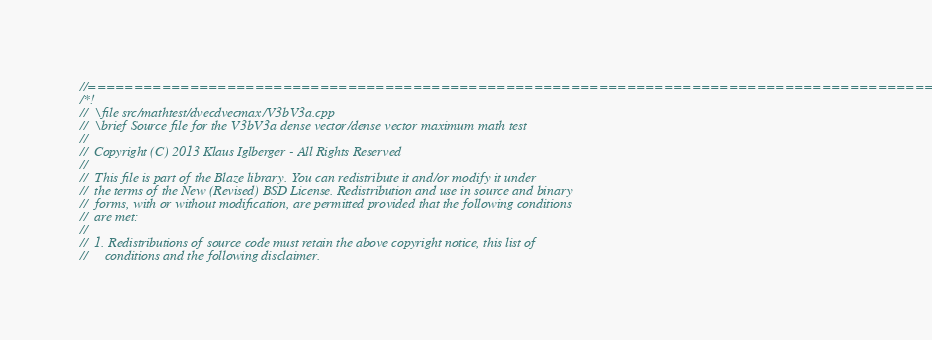Convert code to text. <code><loc_0><loc_0><loc_500><loc_500><_C++_>//=================================================================================================
/*!
//  \file src/mathtest/dvecdvecmax/V3bV3a.cpp
//  \brief Source file for the V3bV3a dense vector/dense vector maximum math test
//
//  Copyright (C) 2013 Klaus Iglberger - All Rights Reserved
//
//  This file is part of the Blaze library. You can redistribute it and/or modify it under
//  the terms of the New (Revised) BSD License. Redistribution and use in source and binary
//  forms, with or without modification, are permitted provided that the following conditions
//  are met:
//
//  1. Redistributions of source code must retain the above copyright notice, this list of
//     conditions and the following disclaimer.</code> 